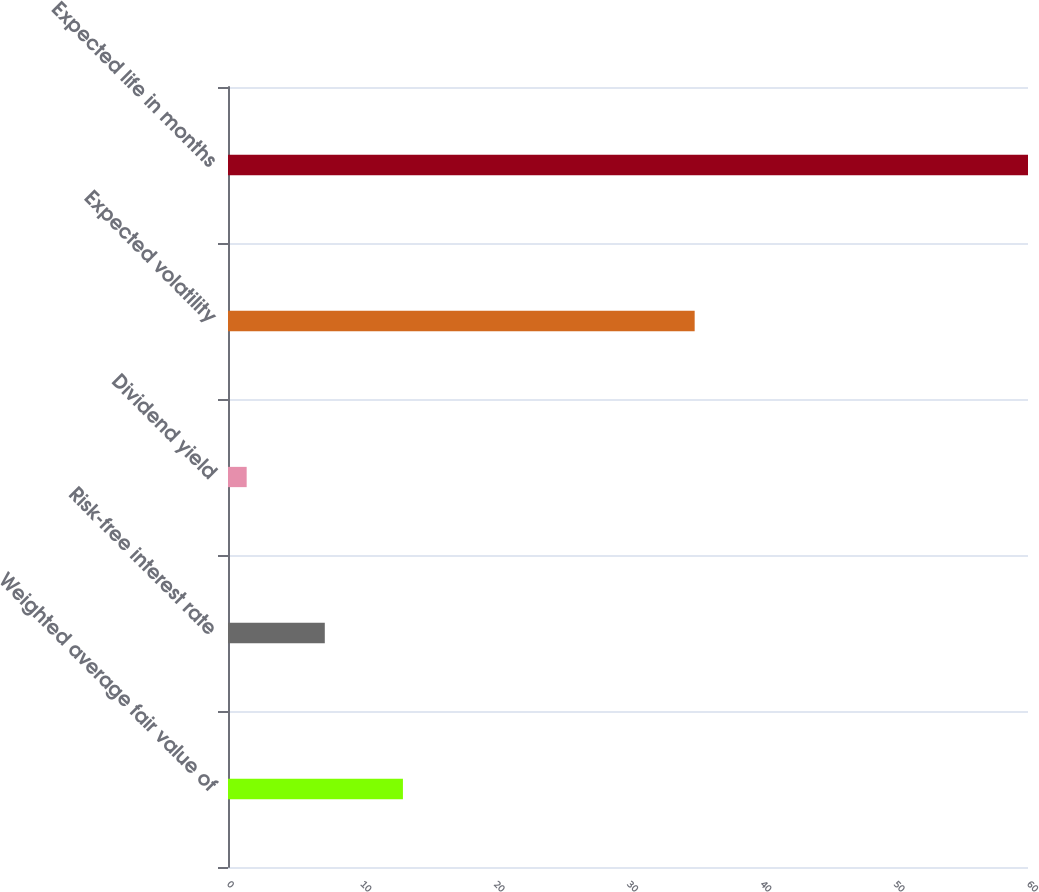Convert chart. <chart><loc_0><loc_0><loc_500><loc_500><bar_chart><fcel>Weighted average fair value of<fcel>Risk-free interest rate<fcel>Dividend yield<fcel>Expected volatility<fcel>Expected life in months<nl><fcel>13.12<fcel>7.26<fcel>1.4<fcel>35<fcel>60<nl></chart> 